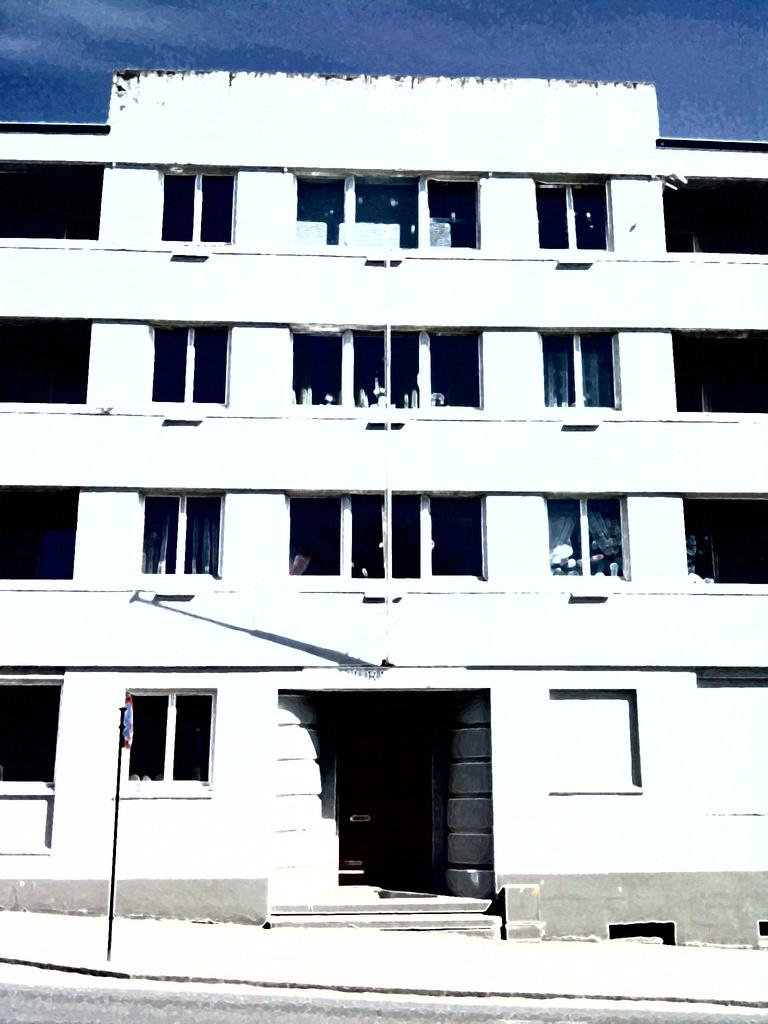What is the main feature of the image? There is a road in the image. What else can be seen in the image besides the road? There is a pole and a building in the background of the image. What is visible at the top of the image? The sky is visible at the top of the image. What type of wool is being used to construct the tent in the image? There is no tent present in the image, so it is not possible to determine what type of wool might be used. 